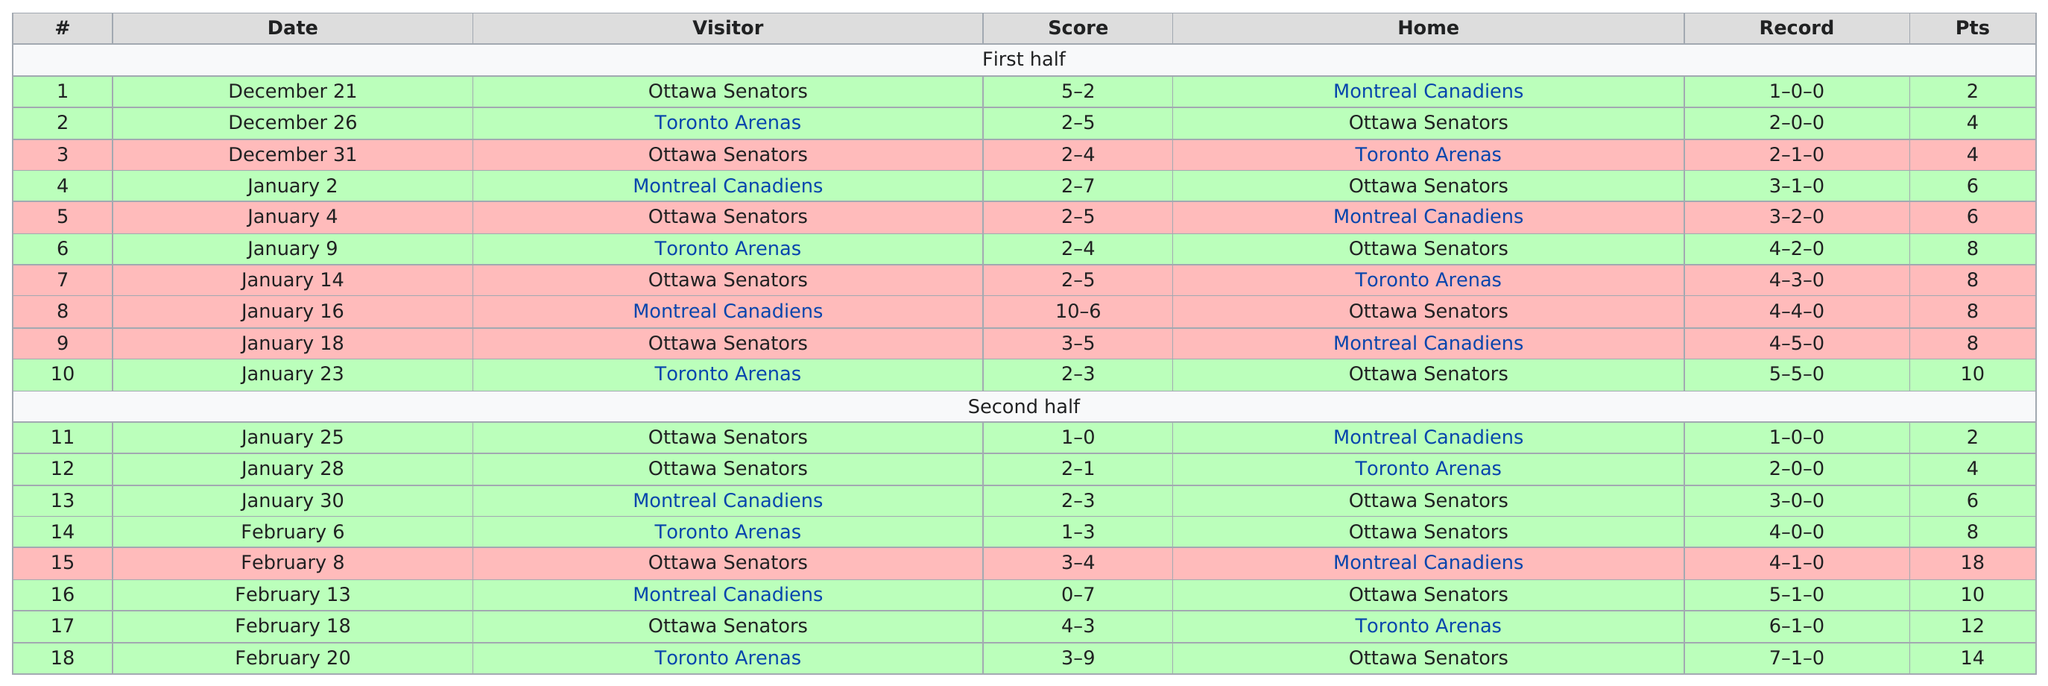Mention a couple of crucial points in this snapshot. I hereby declare that the only shutout of the season was achieved against the Montreal Canadiens. On December 21, the first game was played. December 26 and January 2 have different total scores. The Ottawa Senators' first win in the first half of the regular season was against the Montreal Canadiens. To date, the Senators have played a total of 18 games. 